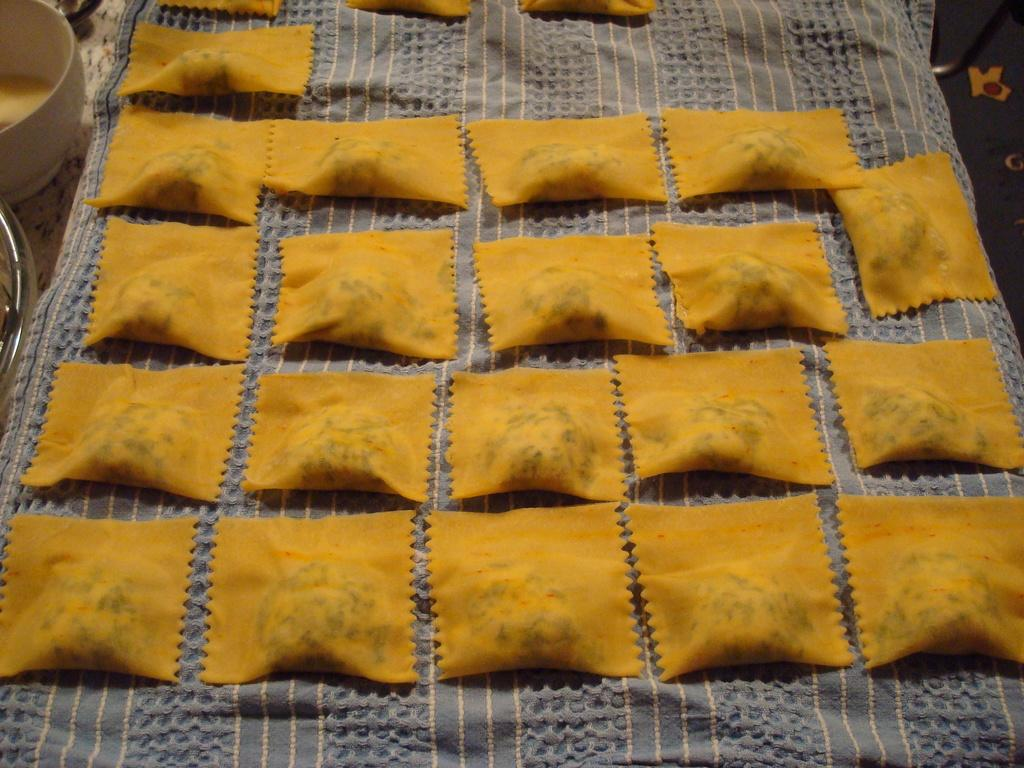What type of food item is visible in the image? The food item is yellow in color. What is the color of the cloth on which the food item is placed? The food item is on a gray color cloth. What other object can be seen in the image? There is a white bowl in the image. Where is the scarecrow located in the image? There is no scarecrow present in the image. What type of alley can be seen in the image? There is no alley present in the image. 